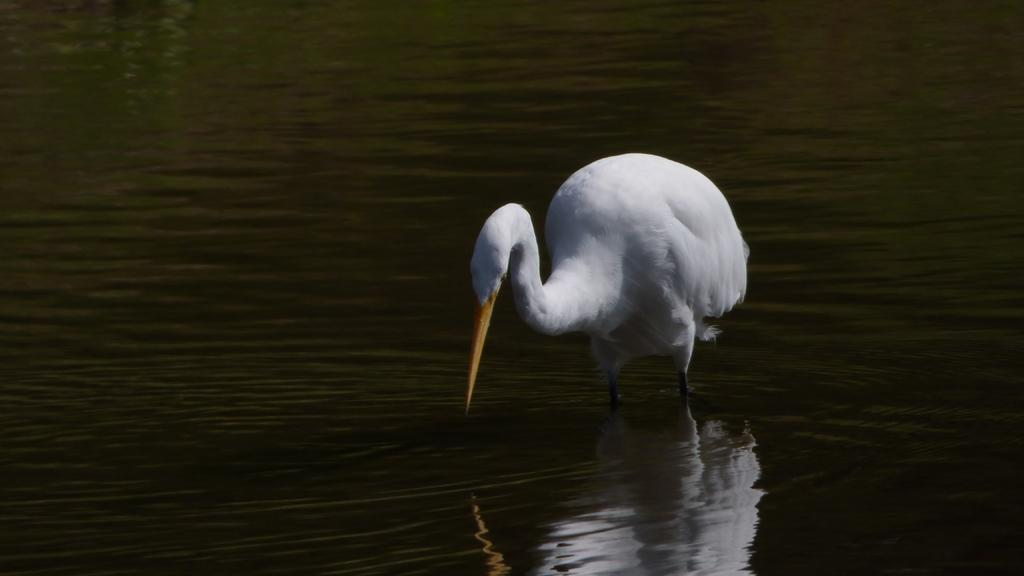What type of animal can be seen in the image? There is a white-colored bird in the image. What is the bird situated in? The bird is situated in water, which is visible in the image. What type of answer can be seen in the image? There is no answer present in the image; it features a white-colored bird in water. 